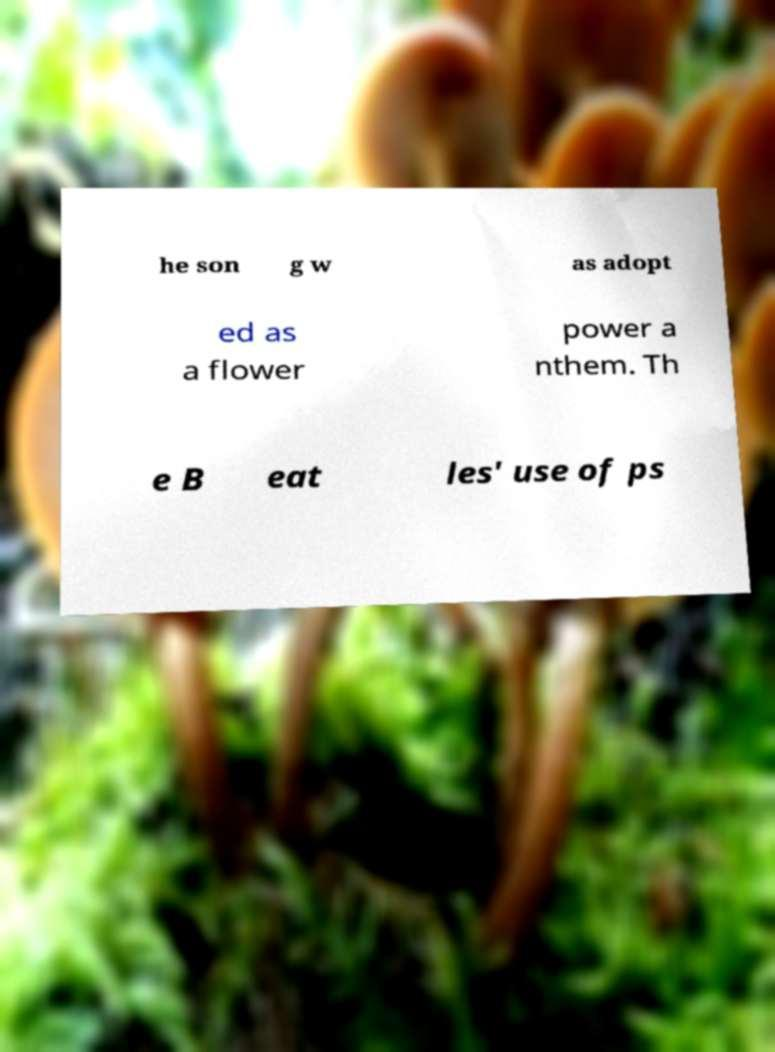Please identify and transcribe the text found in this image. he son g w as adopt ed as a flower power a nthem. Th e B eat les' use of ps 